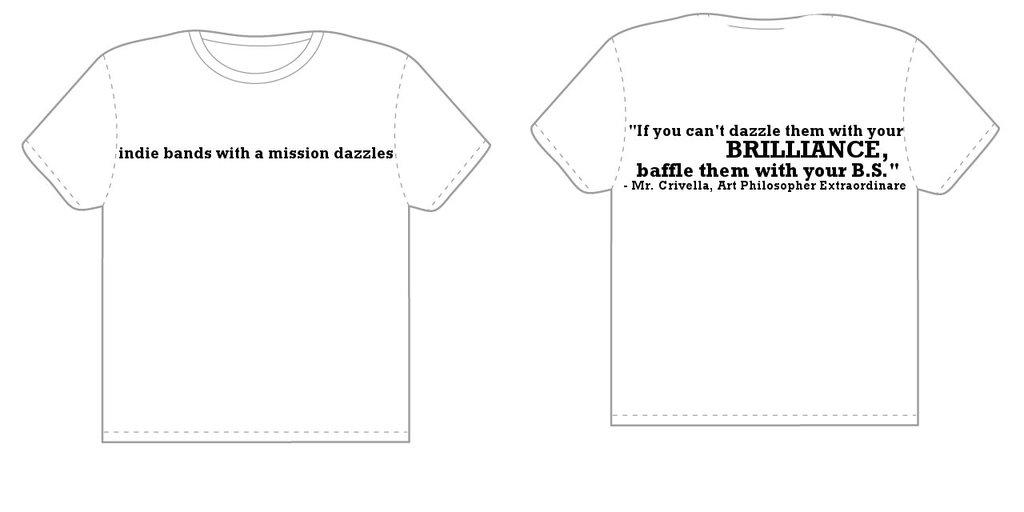<image>
Describe the image concisely. Front of white shirt that has brilliance written on it 